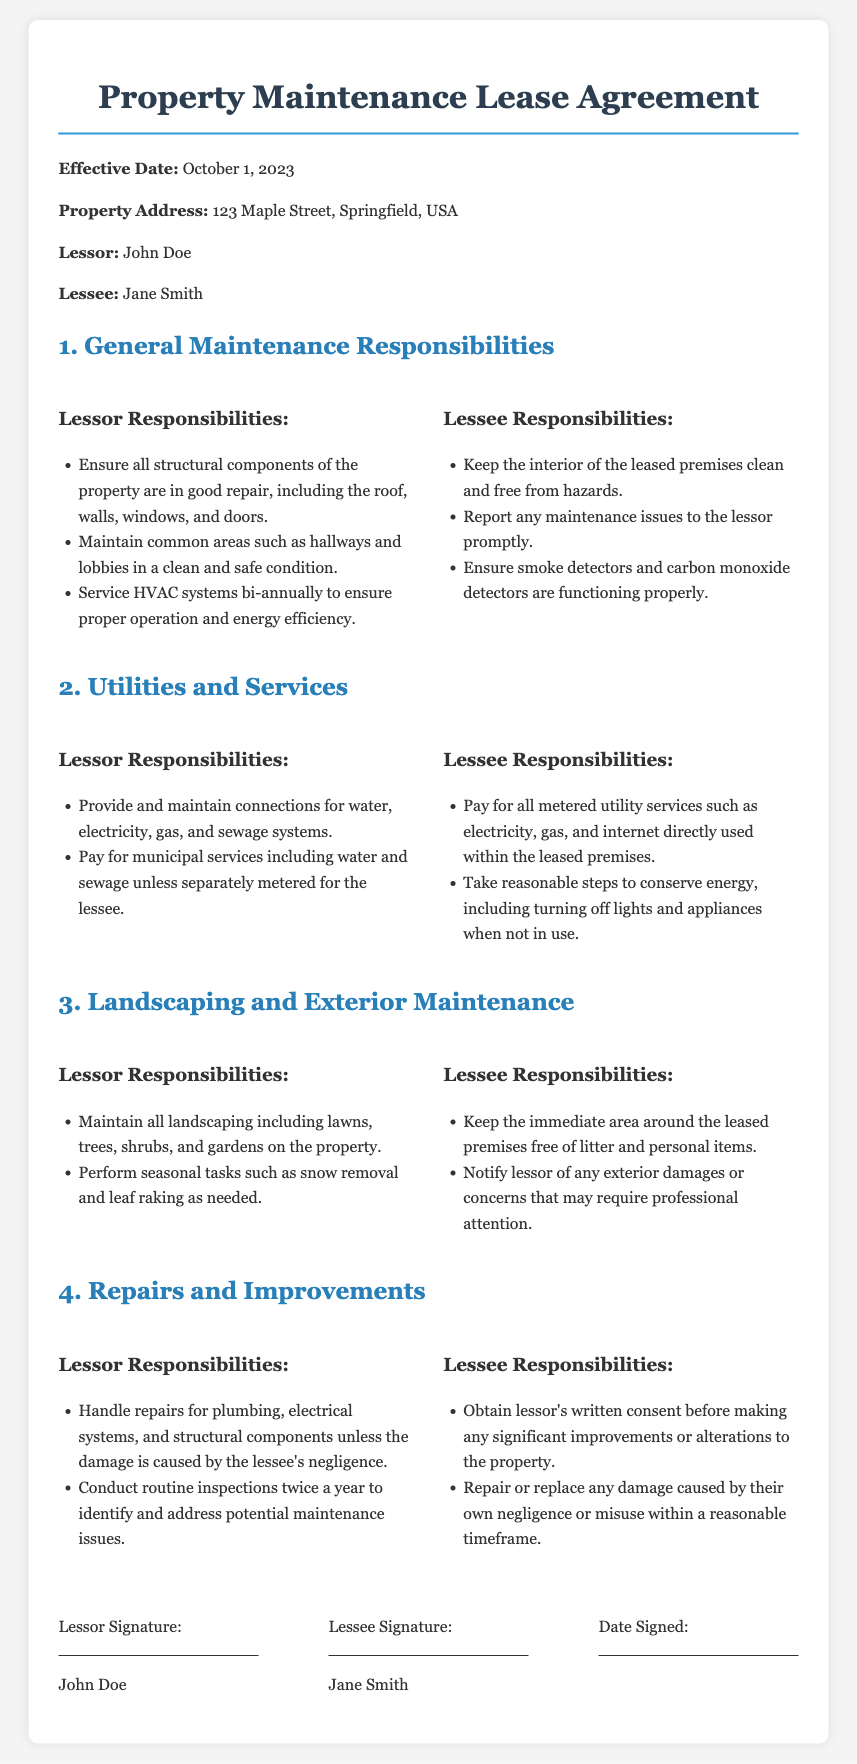What is the effective date of the lease? The effective date is clearly stated in the document as October 1, 2023.
Answer: October 1, 2023 Who is the lessor? The name of the lessor is provided in the document as John Doe.
Answer: John Doe What are the lessee's responsibilities regarding smoke detectors? The document specifies that the lessee must ensure smoke detectors are functioning properly.
Answer: Functioning properly How often must the lessor service the HVAC systems? The frequency of servicing the HVAC systems is mentioned as bi-annually.
Answer: Bi-annually What is the lessee required to do about litter? The document states that the lessee must keep the immediate area free of litter and personal items.
Answer: Free of litter What must the lessee obtain before making improvements? The lessee is required to obtain written consent from the lessor before making significant improvements.
Answer: Written consent How frequently will routine inspections be conducted? The document mentions that routine inspections will be conducted twice a year.
Answer: Twice a year Who is responsible for snow removal? The responsibility for snow removal falls under the lessor's duties as outlined in the landscaping section.
Answer: Lessor 